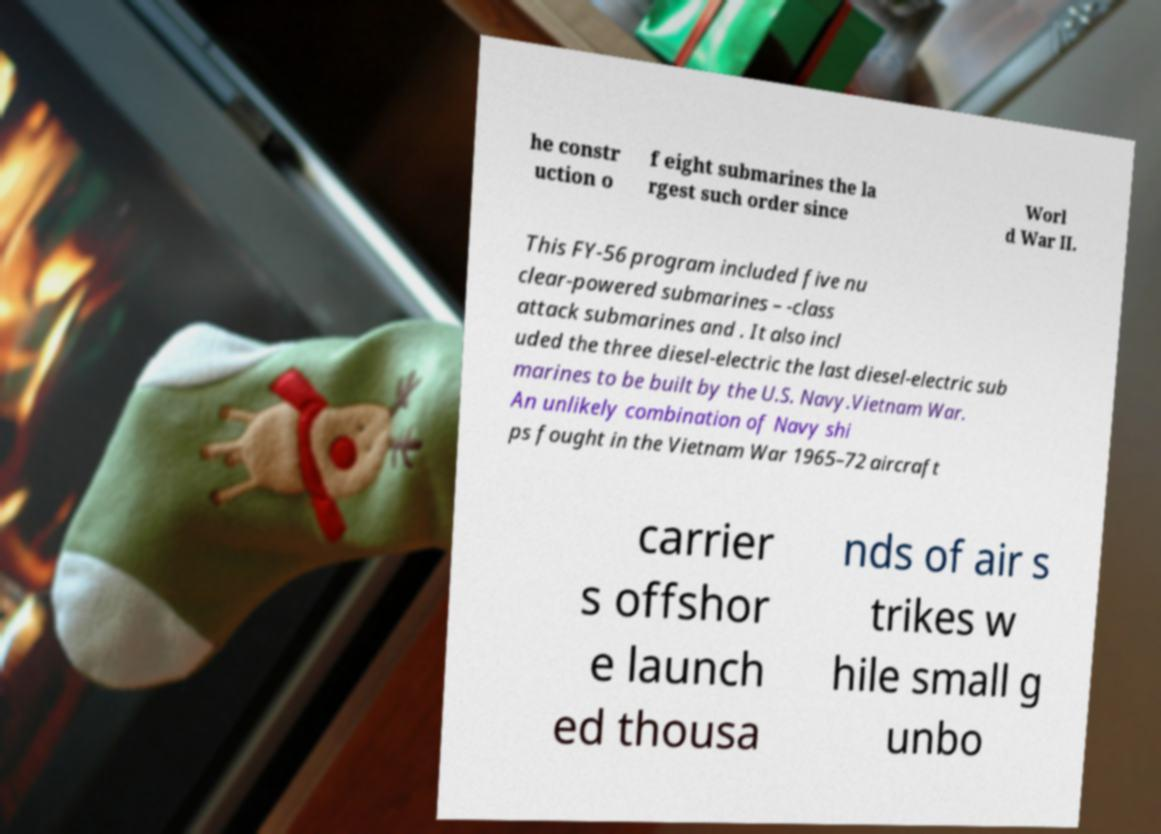Could you extract and type out the text from this image? he constr uction o f eight submarines the la rgest such order since Worl d War II. This FY-56 program included five nu clear-powered submarines – -class attack submarines and . It also incl uded the three diesel-electric the last diesel-electric sub marines to be built by the U.S. Navy.Vietnam War. An unlikely combination of Navy shi ps fought in the Vietnam War 1965–72 aircraft carrier s offshor e launch ed thousa nds of air s trikes w hile small g unbo 